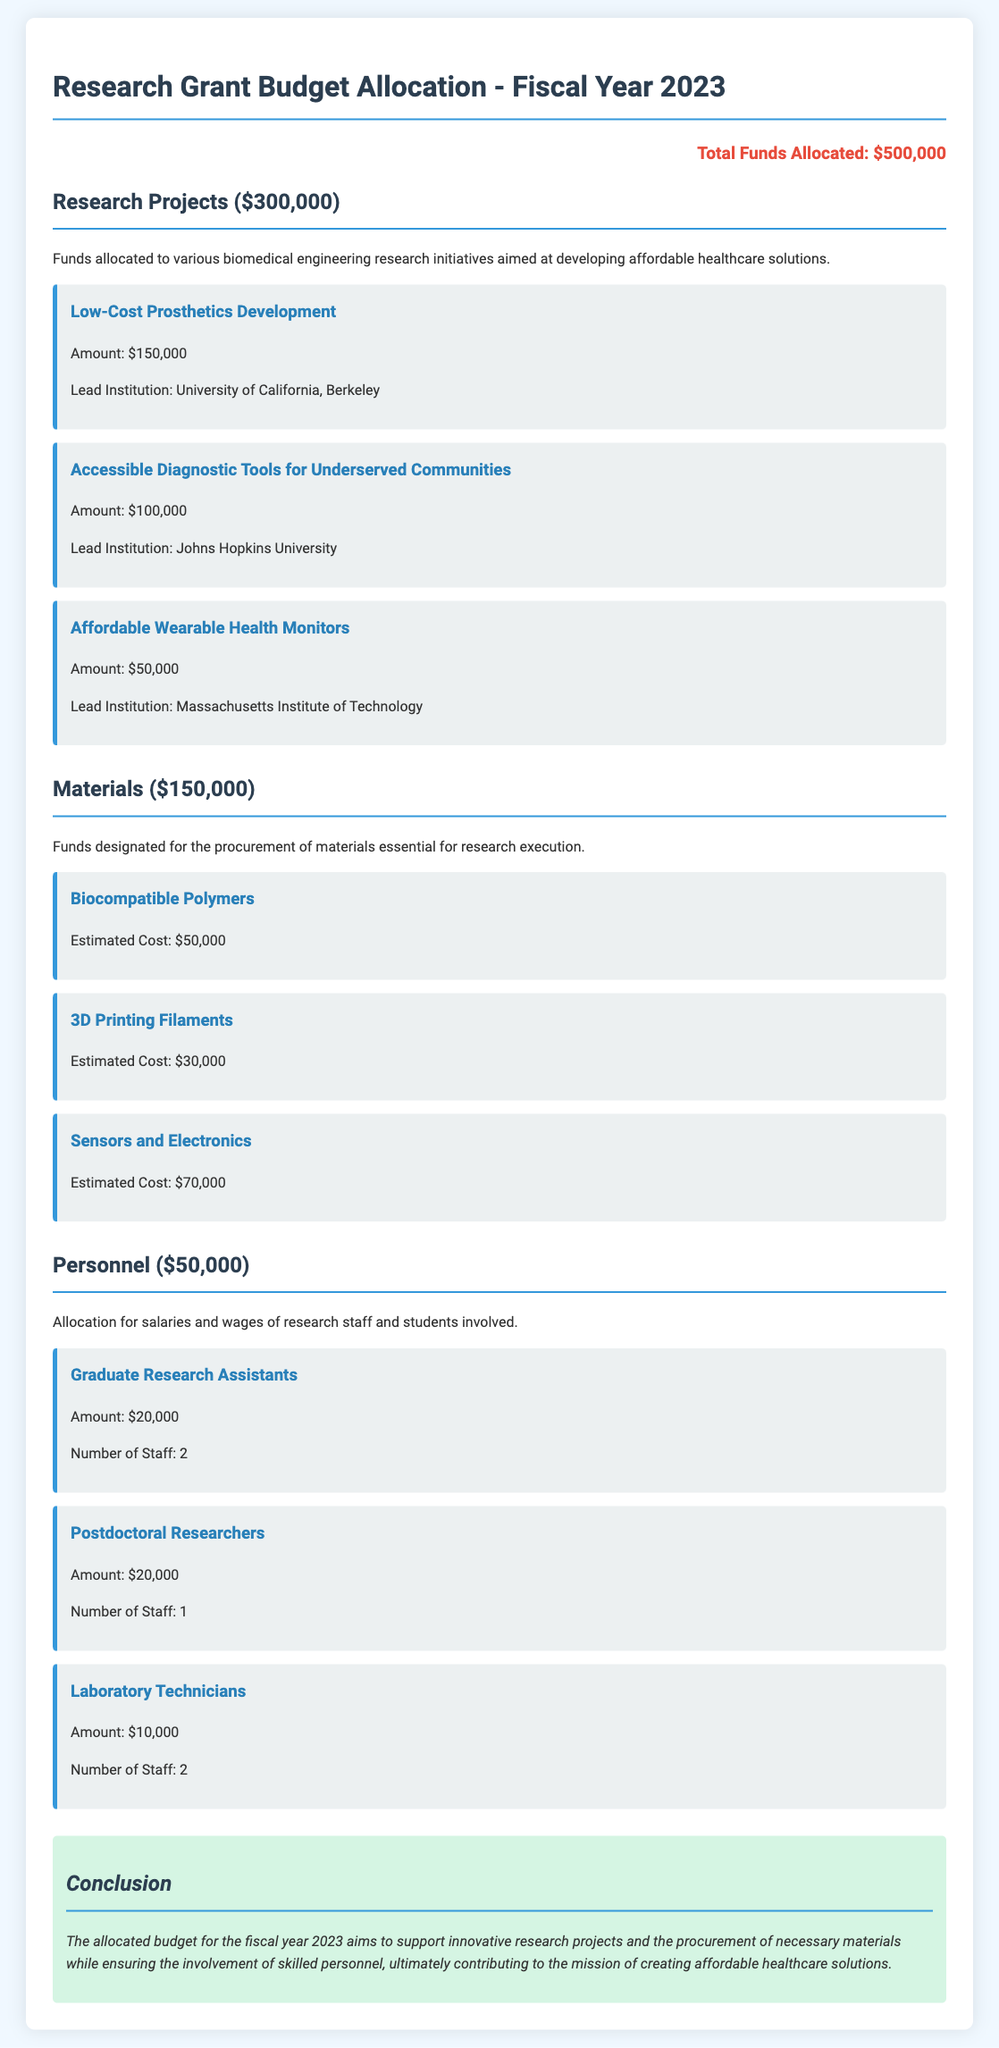what is the total funds allocated? The total funds allocated is stated at the beginning of the document.
Answer: $500,000 how much funding is allocated for research projects? The document specifies the amount designated for research projects in the corresponding section.
Answer: $300,000 which institution leads the Low-Cost Prosthetics Development project? The lead institution for the project is mentioned under the research projects section.
Answer: University of California, Berkeley how much is allocated for materials? The allocation for materials is clearly indicated in its section.
Answer: $150,000 what is the estimated cost for Sensors and Electronics? The estimated cost is provided in the materials section under the corresponding item.
Answer: $70,000 how many Graduate Research Assistants are funded? The number of funded Graduate Research Assistants is stated in the personnel section.
Answer: 2 what is the total amount allocated for personnel? The total amount for personnel can be found in the personnel section of the document.
Answer: $50,000 what type of research does the budget aim to support? The purpose of the budget is summarized in the introduction and conclusion of the document.
Answer: affordable healthcare solutions who is responsible for overseeing the Accessible Diagnostic Tools for Underserved Communities project? The project lead is indicated right below the project title in the research projects section.
Answer: Johns Hopkins University 